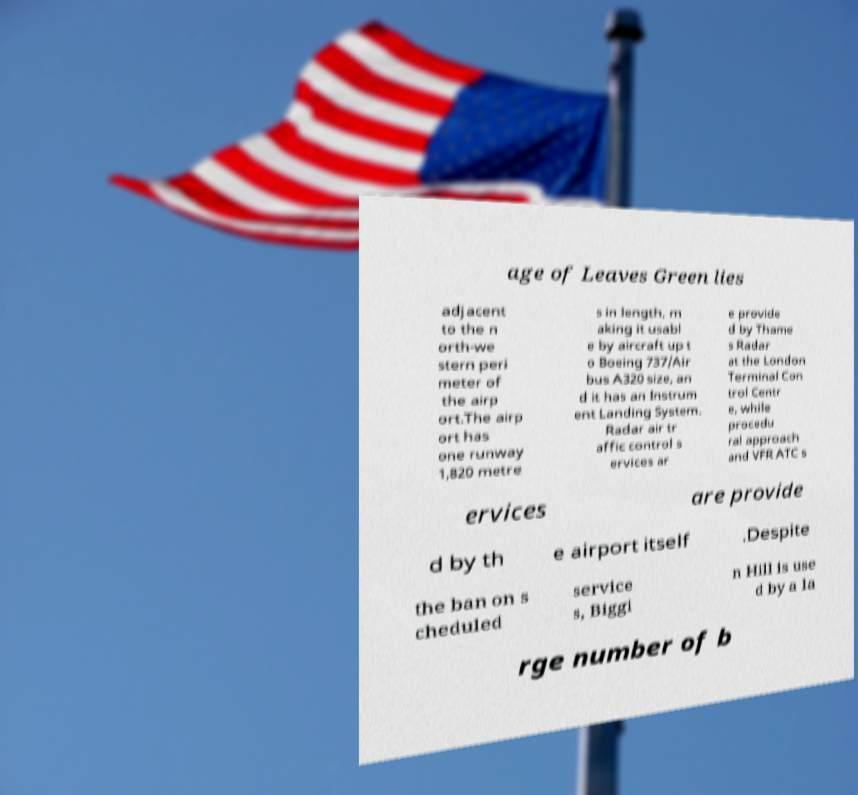For documentation purposes, I need the text within this image transcribed. Could you provide that? age of Leaves Green lies adjacent to the n orth-we stern peri meter of the airp ort.The airp ort has one runway 1,820 metre s in length, m aking it usabl e by aircraft up t o Boeing 737/Air bus A320 size, an d it has an Instrum ent Landing System. Radar air tr affic control s ervices ar e provide d by Thame s Radar at the London Terminal Con trol Centr e, while procedu ral approach and VFR ATC s ervices are provide d by th e airport itself .Despite the ban on s cheduled service s, Biggi n Hill is use d by a la rge number of b 